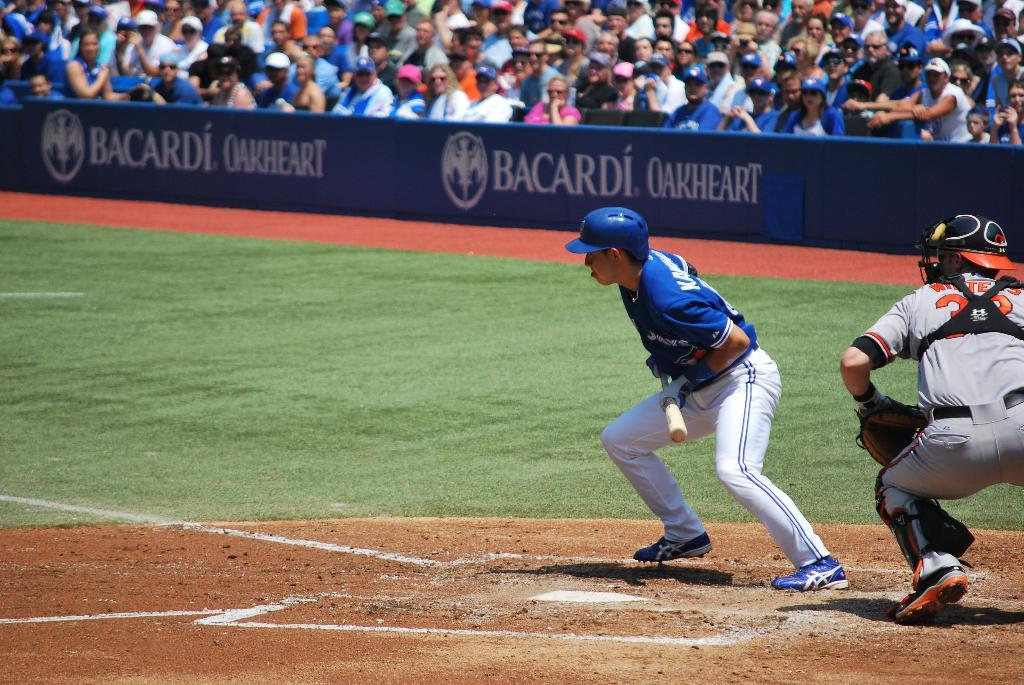<image>
Present a compact description of the photo's key features. A baseball player gets ready to in front of a Bacardi ad on the field 